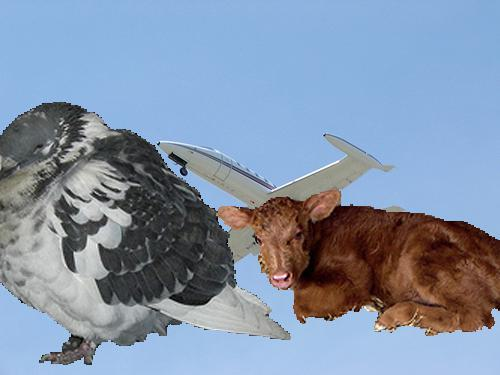Is there an aeroplane in the image? Yes, there is an aeroplane in the image, cleverly integrated with the body of a bird, creating a unique and whimsical composite. 